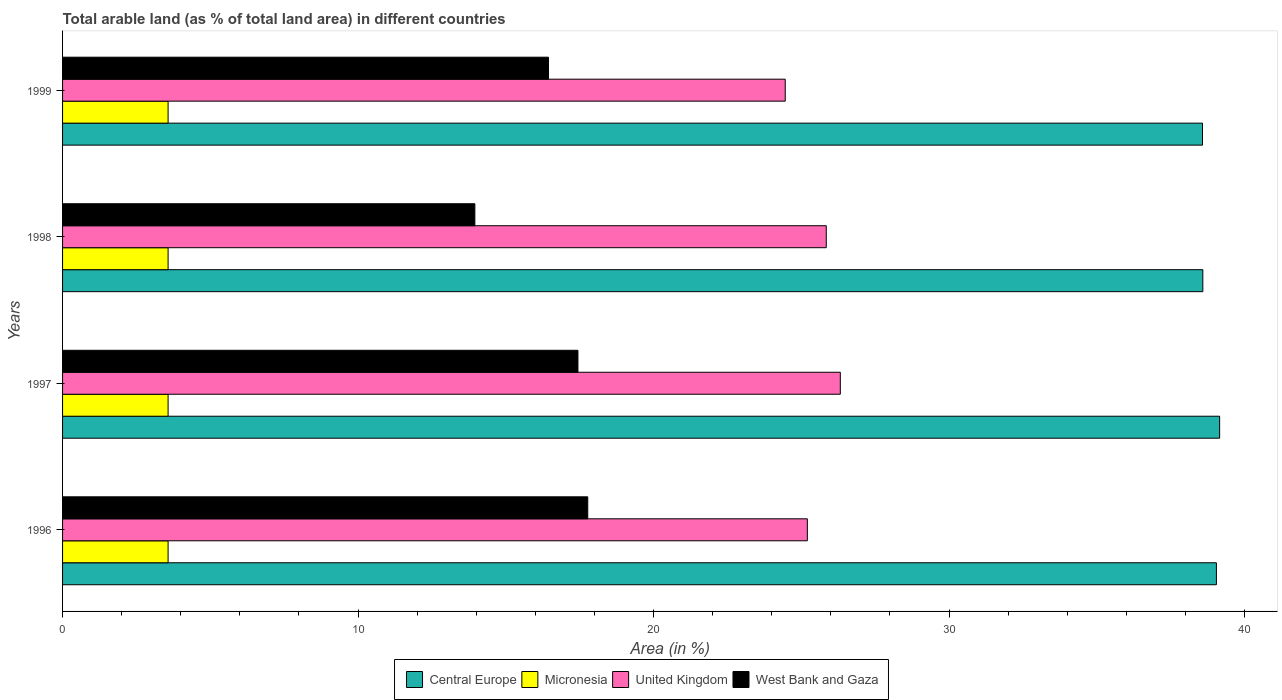How many different coloured bars are there?
Give a very brief answer. 4. How many groups of bars are there?
Provide a succinct answer. 4. Are the number of bars per tick equal to the number of legend labels?
Keep it short and to the point. Yes. Are the number of bars on each tick of the Y-axis equal?
Make the answer very short. Yes. How many bars are there on the 4th tick from the top?
Make the answer very short. 4. What is the label of the 2nd group of bars from the top?
Give a very brief answer. 1998. What is the percentage of arable land in West Bank and Gaza in 1996?
Ensure brevity in your answer.  17.77. Across all years, what is the maximum percentage of arable land in United Kingdom?
Offer a terse response. 26.32. Across all years, what is the minimum percentage of arable land in United Kingdom?
Give a very brief answer. 24.46. In which year was the percentage of arable land in Central Europe maximum?
Make the answer very short. 1997. In which year was the percentage of arable land in West Bank and Gaza minimum?
Your answer should be very brief. 1998. What is the total percentage of arable land in United Kingdom in the graph?
Keep it short and to the point. 101.83. What is the difference between the percentage of arable land in West Bank and Gaza in 1996 and that in 1997?
Make the answer very short. 0.33. What is the difference between the percentage of arable land in United Kingdom in 1996 and the percentage of arable land in Central Europe in 1997?
Ensure brevity in your answer.  -13.95. What is the average percentage of arable land in United Kingdom per year?
Give a very brief answer. 25.46. In the year 1997, what is the difference between the percentage of arable land in Central Europe and percentage of arable land in West Bank and Gaza?
Provide a succinct answer. 21.72. In how many years, is the percentage of arable land in United Kingdom greater than 26 %?
Your answer should be compact. 1. What is the ratio of the percentage of arable land in Micronesia in 1996 to that in 1997?
Offer a terse response. 1. Is the difference between the percentage of arable land in Central Europe in 1997 and 1998 greater than the difference between the percentage of arable land in West Bank and Gaza in 1997 and 1998?
Your answer should be compact. No. What is the difference between the highest and the second highest percentage of arable land in Central Europe?
Offer a terse response. 0.11. What is the difference between the highest and the lowest percentage of arable land in West Bank and Gaza?
Provide a succinct answer. 3.82. In how many years, is the percentage of arable land in West Bank and Gaza greater than the average percentage of arable land in West Bank and Gaza taken over all years?
Offer a very short reply. 3. What does the 4th bar from the top in 1997 represents?
Provide a short and direct response. Central Europe. What does the 2nd bar from the bottom in 1996 represents?
Offer a very short reply. Micronesia. Is it the case that in every year, the sum of the percentage of arable land in Central Europe and percentage of arable land in West Bank and Gaza is greater than the percentage of arable land in United Kingdom?
Your answer should be compact. Yes. How many bars are there?
Keep it short and to the point. 16. Are all the bars in the graph horizontal?
Ensure brevity in your answer.  Yes. How many years are there in the graph?
Your answer should be very brief. 4. What is the difference between two consecutive major ticks on the X-axis?
Offer a terse response. 10. Are the values on the major ticks of X-axis written in scientific E-notation?
Offer a very short reply. No. How are the legend labels stacked?
Provide a succinct answer. Horizontal. What is the title of the graph?
Your response must be concise. Total arable land (as % of total land area) in different countries. What is the label or title of the X-axis?
Your answer should be very brief. Area (in %). What is the label or title of the Y-axis?
Offer a very short reply. Years. What is the Area (in %) in Central Europe in 1996?
Keep it short and to the point. 39.05. What is the Area (in %) in Micronesia in 1996?
Keep it short and to the point. 3.57. What is the Area (in %) of United Kingdom in 1996?
Provide a succinct answer. 25.21. What is the Area (in %) of West Bank and Gaza in 1996?
Make the answer very short. 17.77. What is the Area (in %) of Central Europe in 1997?
Provide a succinct answer. 39.16. What is the Area (in %) in Micronesia in 1997?
Keep it short and to the point. 3.57. What is the Area (in %) of United Kingdom in 1997?
Provide a short and direct response. 26.32. What is the Area (in %) in West Bank and Gaza in 1997?
Your answer should be compact. 17.44. What is the Area (in %) of Central Europe in 1998?
Your answer should be very brief. 38.59. What is the Area (in %) in Micronesia in 1998?
Ensure brevity in your answer.  3.57. What is the Area (in %) of United Kingdom in 1998?
Make the answer very short. 25.85. What is the Area (in %) of West Bank and Gaza in 1998?
Your answer should be very brief. 13.95. What is the Area (in %) in Central Europe in 1999?
Your response must be concise. 38.58. What is the Area (in %) of Micronesia in 1999?
Provide a short and direct response. 3.57. What is the Area (in %) of United Kingdom in 1999?
Keep it short and to the point. 24.46. What is the Area (in %) in West Bank and Gaza in 1999?
Offer a very short reply. 16.45. Across all years, what is the maximum Area (in %) in Central Europe?
Provide a short and direct response. 39.16. Across all years, what is the maximum Area (in %) of Micronesia?
Your response must be concise. 3.57. Across all years, what is the maximum Area (in %) of United Kingdom?
Your response must be concise. 26.32. Across all years, what is the maximum Area (in %) of West Bank and Gaza?
Your answer should be very brief. 17.77. Across all years, what is the minimum Area (in %) of Central Europe?
Your answer should be compact. 38.58. Across all years, what is the minimum Area (in %) of Micronesia?
Provide a succinct answer. 3.57. Across all years, what is the minimum Area (in %) in United Kingdom?
Your answer should be very brief. 24.46. Across all years, what is the minimum Area (in %) in West Bank and Gaza?
Your response must be concise. 13.95. What is the total Area (in %) in Central Europe in the graph?
Keep it short and to the point. 155.38. What is the total Area (in %) of Micronesia in the graph?
Offer a terse response. 14.29. What is the total Area (in %) of United Kingdom in the graph?
Keep it short and to the point. 101.83. What is the total Area (in %) of West Bank and Gaza in the graph?
Keep it short and to the point. 65.61. What is the difference between the Area (in %) of Central Europe in 1996 and that in 1997?
Offer a very short reply. -0.11. What is the difference between the Area (in %) in Micronesia in 1996 and that in 1997?
Your response must be concise. 0. What is the difference between the Area (in %) in United Kingdom in 1996 and that in 1997?
Provide a short and direct response. -1.12. What is the difference between the Area (in %) in West Bank and Gaza in 1996 and that in 1997?
Provide a short and direct response. 0.33. What is the difference between the Area (in %) in Central Europe in 1996 and that in 1998?
Keep it short and to the point. 0.46. What is the difference between the Area (in %) in United Kingdom in 1996 and that in 1998?
Offer a very short reply. -0.64. What is the difference between the Area (in %) in West Bank and Gaza in 1996 and that in 1998?
Provide a succinct answer. 3.82. What is the difference between the Area (in %) in Central Europe in 1996 and that in 1999?
Ensure brevity in your answer.  0.47. What is the difference between the Area (in %) of United Kingdom in 1996 and that in 1999?
Ensure brevity in your answer.  0.75. What is the difference between the Area (in %) of West Bank and Gaza in 1996 and that in 1999?
Your answer should be very brief. 1.33. What is the difference between the Area (in %) in Central Europe in 1997 and that in 1998?
Provide a short and direct response. 0.57. What is the difference between the Area (in %) in United Kingdom in 1997 and that in 1998?
Give a very brief answer. 0.48. What is the difference between the Area (in %) of West Bank and Gaza in 1997 and that in 1998?
Provide a short and direct response. 3.49. What is the difference between the Area (in %) of Central Europe in 1997 and that in 1999?
Your response must be concise. 0.58. What is the difference between the Area (in %) in Micronesia in 1997 and that in 1999?
Make the answer very short. 0. What is the difference between the Area (in %) of United Kingdom in 1997 and that in 1999?
Provide a succinct answer. 1.86. What is the difference between the Area (in %) of West Bank and Gaza in 1997 and that in 1999?
Your answer should be very brief. 1. What is the difference between the Area (in %) in Central Europe in 1998 and that in 1999?
Offer a terse response. 0.01. What is the difference between the Area (in %) in Micronesia in 1998 and that in 1999?
Give a very brief answer. 0. What is the difference between the Area (in %) in United Kingdom in 1998 and that in 1999?
Your answer should be very brief. 1.39. What is the difference between the Area (in %) of West Bank and Gaza in 1998 and that in 1999?
Make the answer very short. -2.49. What is the difference between the Area (in %) in Central Europe in 1996 and the Area (in %) in Micronesia in 1997?
Provide a succinct answer. 35.48. What is the difference between the Area (in %) in Central Europe in 1996 and the Area (in %) in United Kingdom in 1997?
Your response must be concise. 12.73. What is the difference between the Area (in %) in Central Europe in 1996 and the Area (in %) in West Bank and Gaza in 1997?
Ensure brevity in your answer.  21.61. What is the difference between the Area (in %) of Micronesia in 1996 and the Area (in %) of United Kingdom in 1997?
Your answer should be compact. -22.75. What is the difference between the Area (in %) of Micronesia in 1996 and the Area (in %) of West Bank and Gaza in 1997?
Give a very brief answer. -13.87. What is the difference between the Area (in %) in United Kingdom in 1996 and the Area (in %) in West Bank and Gaza in 1997?
Your answer should be very brief. 7.76. What is the difference between the Area (in %) in Central Europe in 1996 and the Area (in %) in Micronesia in 1998?
Make the answer very short. 35.48. What is the difference between the Area (in %) of Central Europe in 1996 and the Area (in %) of United Kingdom in 1998?
Ensure brevity in your answer.  13.2. What is the difference between the Area (in %) of Central Europe in 1996 and the Area (in %) of West Bank and Gaza in 1998?
Offer a very short reply. 25.1. What is the difference between the Area (in %) in Micronesia in 1996 and the Area (in %) in United Kingdom in 1998?
Your response must be concise. -22.27. What is the difference between the Area (in %) in Micronesia in 1996 and the Area (in %) in West Bank and Gaza in 1998?
Ensure brevity in your answer.  -10.38. What is the difference between the Area (in %) in United Kingdom in 1996 and the Area (in %) in West Bank and Gaza in 1998?
Give a very brief answer. 11.25. What is the difference between the Area (in %) in Central Europe in 1996 and the Area (in %) in Micronesia in 1999?
Ensure brevity in your answer.  35.48. What is the difference between the Area (in %) of Central Europe in 1996 and the Area (in %) of United Kingdom in 1999?
Your answer should be very brief. 14.59. What is the difference between the Area (in %) of Central Europe in 1996 and the Area (in %) of West Bank and Gaza in 1999?
Your answer should be very brief. 22.6. What is the difference between the Area (in %) of Micronesia in 1996 and the Area (in %) of United Kingdom in 1999?
Your response must be concise. -20.89. What is the difference between the Area (in %) of Micronesia in 1996 and the Area (in %) of West Bank and Gaza in 1999?
Your answer should be compact. -12.87. What is the difference between the Area (in %) in United Kingdom in 1996 and the Area (in %) in West Bank and Gaza in 1999?
Provide a succinct answer. 8.76. What is the difference between the Area (in %) in Central Europe in 1997 and the Area (in %) in Micronesia in 1998?
Offer a very short reply. 35.59. What is the difference between the Area (in %) of Central Europe in 1997 and the Area (in %) of United Kingdom in 1998?
Make the answer very short. 13.31. What is the difference between the Area (in %) of Central Europe in 1997 and the Area (in %) of West Bank and Gaza in 1998?
Your answer should be very brief. 25.21. What is the difference between the Area (in %) of Micronesia in 1997 and the Area (in %) of United Kingdom in 1998?
Ensure brevity in your answer.  -22.27. What is the difference between the Area (in %) of Micronesia in 1997 and the Area (in %) of West Bank and Gaza in 1998?
Provide a short and direct response. -10.38. What is the difference between the Area (in %) of United Kingdom in 1997 and the Area (in %) of West Bank and Gaza in 1998?
Your response must be concise. 12.37. What is the difference between the Area (in %) of Central Europe in 1997 and the Area (in %) of Micronesia in 1999?
Your answer should be very brief. 35.59. What is the difference between the Area (in %) in Central Europe in 1997 and the Area (in %) in United Kingdom in 1999?
Your answer should be very brief. 14.7. What is the difference between the Area (in %) in Central Europe in 1997 and the Area (in %) in West Bank and Gaza in 1999?
Provide a short and direct response. 22.71. What is the difference between the Area (in %) in Micronesia in 1997 and the Area (in %) in United Kingdom in 1999?
Your response must be concise. -20.89. What is the difference between the Area (in %) of Micronesia in 1997 and the Area (in %) of West Bank and Gaza in 1999?
Your response must be concise. -12.87. What is the difference between the Area (in %) of United Kingdom in 1997 and the Area (in %) of West Bank and Gaza in 1999?
Your response must be concise. 9.88. What is the difference between the Area (in %) of Central Europe in 1998 and the Area (in %) of Micronesia in 1999?
Offer a very short reply. 35.02. What is the difference between the Area (in %) in Central Europe in 1998 and the Area (in %) in United Kingdom in 1999?
Your response must be concise. 14.13. What is the difference between the Area (in %) in Central Europe in 1998 and the Area (in %) in West Bank and Gaza in 1999?
Provide a succinct answer. 22.14. What is the difference between the Area (in %) in Micronesia in 1998 and the Area (in %) in United Kingdom in 1999?
Give a very brief answer. -20.89. What is the difference between the Area (in %) in Micronesia in 1998 and the Area (in %) in West Bank and Gaza in 1999?
Give a very brief answer. -12.87. What is the difference between the Area (in %) of United Kingdom in 1998 and the Area (in %) of West Bank and Gaza in 1999?
Make the answer very short. 9.4. What is the average Area (in %) in Central Europe per year?
Ensure brevity in your answer.  38.84. What is the average Area (in %) in Micronesia per year?
Ensure brevity in your answer.  3.57. What is the average Area (in %) of United Kingdom per year?
Keep it short and to the point. 25.46. What is the average Area (in %) of West Bank and Gaza per year?
Your answer should be compact. 16.4. In the year 1996, what is the difference between the Area (in %) in Central Europe and Area (in %) in Micronesia?
Ensure brevity in your answer.  35.48. In the year 1996, what is the difference between the Area (in %) of Central Europe and Area (in %) of United Kingdom?
Your response must be concise. 13.84. In the year 1996, what is the difference between the Area (in %) in Central Europe and Area (in %) in West Bank and Gaza?
Offer a terse response. 21.28. In the year 1996, what is the difference between the Area (in %) in Micronesia and Area (in %) in United Kingdom?
Ensure brevity in your answer.  -21.63. In the year 1996, what is the difference between the Area (in %) in Micronesia and Area (in %) in West Bank and Gaza?
Your answer should be compact. -14.2. In the year 1996, what is the difference between the Area (in %) of United Kingdom and Area (in %) of West Bank and Gaza?
Give a very brief answer. 7.43. In the year 1997, what is the difference between the Area (in %) in Central Europe and Area (in %) in Micronesia?
Provide a short and direct response. 35.59. In the year 1997, what is the difference between the Area (in %) of Central Europe and Area (in %) of United Kingdom?
Offer a terse response. 12.84. In the year 1997, what is the difference between the Area (in %) in Central Europe and Area (in %) in West Bank and Gaza?
Make the answer very short. 21.72. In the year 1997, what is the difference between the Area (in %) in Micronesia and Area (in %) in United Kingdom?
Keep it short and to the point. -22.75. In the year 1997, what is the difference between the Area (in %) of Micronesia and Area (in %) of West Bank and Gaza?
Your answer should be compact. -13.87. In the year 1997, what is the difference between the Area (in %) of United Kingdom and Area (in %) of West Bank and Gaza?
Your answer should be very brief. 8.88. In the year 1998, what is the difference between the Area (in %) of Central Europe and Area (in %) of Micronesia?
Offer a terse response. 35.02. In the year 1998, what is the difference between the Area (in %) of Central Europe and Area (in %) of United Kingdom?
Your answer should be very brief. 12.74. In the year 1998, what is the difference between the Area (in %) of Central Europe and Area (in %) of West Bank and Gaza?
Your response must be concise. 24.64. In the year 1998, what is the difference between the Area (in %) in Micronesia and Area (in %) in United Kingdom?
Provide a succinct answer. -22.27. In the year 1998, what is the difference between the Area (in %) of Micronesia and Area (in %) of West Bank and Gaza?
Keep it short and to the point. -10.38. In the year 1998, what is the difference between the Area (in %) in United Kingdom and Area (in %) in West Bank and Gaza?
Offer a terse response. 11.89. In the year 1999, what is the difference between the Area (in %) of Central Europe and Area (in %) of Micronesia?
Give a very brief answer. 35.01. In the year 1999, what is the difference between the Area (in %) in Central Europe and Area (in %) in United Kingdom?
Keep it short and to the point. 14.12. In the year 1999, what is the difference between the Area (in %) in Central Europe and Area (in %) in West Bank and Gaza?
Offer a terse response. 22.13. In the year 1999, what is the difference between the Area (in %) in Micronesia and Area (in %) in United Kingdom?
Make the answer very short. -20.89. In the year 1999, what is the difference between the Area (in %) in Micronesia and Area (in %) in West Bank and Gaza?
Your answer should be compact. -12.87. In the year 1999, what is the difference between the Area (in %) in United Kingdom and Area (in %) in West Bank and Gaza?
Offer a terse response. 8.01. What is the ratio of the Area (in %) in Central Europe in 1996 to that in 1997?
Your answer should be compact. 1. What is the ratio of the Area (in %) in Micronesia in 1996 to that in 1997?
Offer a very short reply. 1. What is the ratio of the Area (in %) of United Kingdom in 1996 to that in 1997?
Offer a very short reply. 0.96. What is the ratio of the Area (in %) of West Bank and Gaza in 1996 to that in 1997?
Give a very brief answer. 1.02. What is the ratio of the Area (in %) of Central Europe in 1996 to that in 1998?
Your response must be concise. 1.01. What is the ratio of the Area (in %) in United Kingdom in 1996 to that in 1998?
Your response must be concise. 0.98. What is the ratio of the Area (in %) of West Bank and Gaza in 1996 to that in 1998?
Ensure brevity in your answer.  1.27. What is the ratio of the Area (in %) of Central Europe in 1996 to that in 1999?
Give a very brief answer. 1.01. What is the ratio of the Area (in %) in Micronesia in 1996 to that in 1999?
Your answer should be very brief. 1. What is the ratio of the Area (in %) in United Kingdom in 1996 to that in 1999?
Ensure brevity in your answer.  1.03. What is the ratio of the Area (in %) of West Bank and Gaza in 1996 to that in 1999?
Your response must be concise. 1.08. What is the ratio of the Area (in %) in Central Europe in 1997 to that in 1998?
Offer a very short reply. 1.01. What is the ratio of the Area (in %) in United Kingdom in 1997 to that in 1998?
Offer a terse response. 1.02. What is the ratio of the Area (in %) in West Bank and Gaza in 1997 to that in 1998?
Ensure brevity in your answer.  1.25. What is the ratio of the Area (in %) in United Kingdom in 1997 to that in 1999?
Provide a short and direct response. 1.08. What is the ratio of the Area (in %) in West Bank and Gaza in 1997 to that in 1999?
Keep it short and to the point. 1.06. What is the ratio of the Area (in %) in United Kingdom in 1998 to that in 1999?
Your answer should be compact. 1.06. What is the ratio of the Area (in %) of West Bank and Gaza in 1998 to that in 1999?
Your answer should be very brief. 0.85. What is the difference between the highest and the second highest Area (in %) in Central Europe?
Give a very brief answer. 0.11. What is the difference between the highest and the second highest Area (in %) in Micronesia?
Keep it short and to the point. 0. What is the difference between the highest and the second highest Area (in %) of United Kingdom?
Provide a succinct answer. 0.48. What is the difference between the highest and the second highest Area (in %) in West Bank and Gaza?
Make the answer very short. 0.33. What is the difference between the highest and the lowest Area (in %) of Central Europe?
Make the answer very short. 0.58. What is the difference between the highest and the lowest Area (in %) of Micronesia?
Your answer should be very brief. 0. What is the difference between the highest and the lowest Area (in %) of United Kingdom?
Make the answer very short. 1.86. What is the difference between the highest and the lowest Area (in %) in West Bank and Gaza?
Make the answer very short. 3.82. 